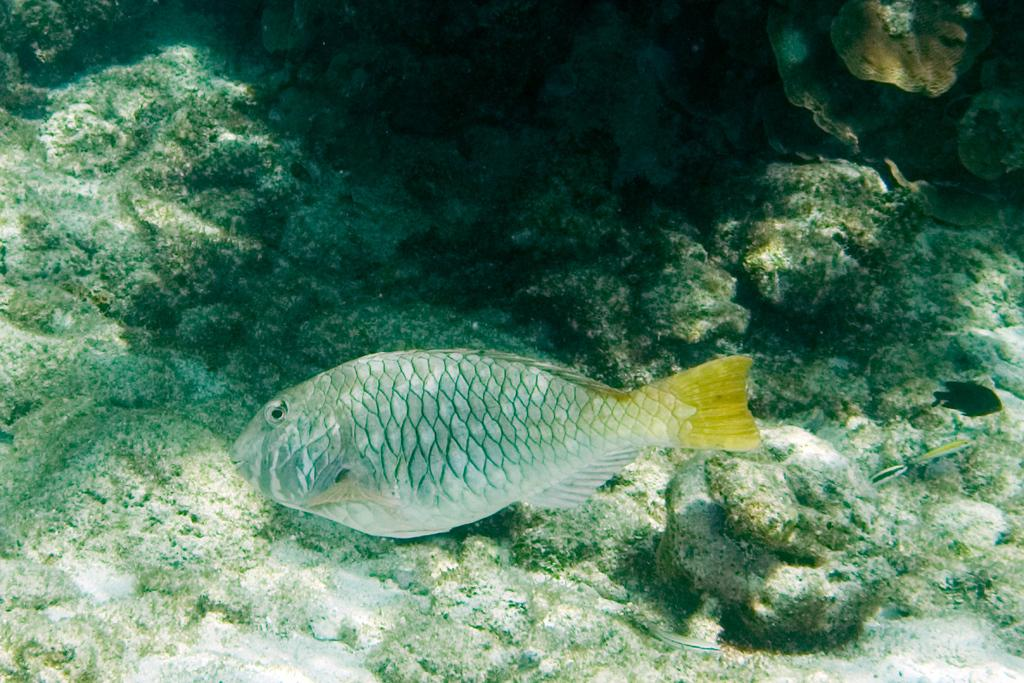What type of animal is in the image? There is a beautiful fish in the image. What is the fish doing in the image? The fish is swimming in the water. What type of glue is being used to perform the operation on the fish in the image? There is no operation or glue present in the image; it simply shows a fish swimming in the water. 